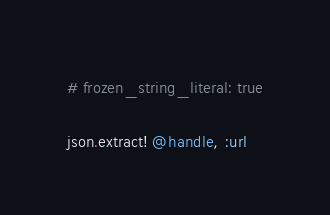Convert code to text. <code><loc_0><loc_0><loc_500><loc_500><_Ruby_># frozen_string_literal: true

json.extract! @handle, :url
</code> 